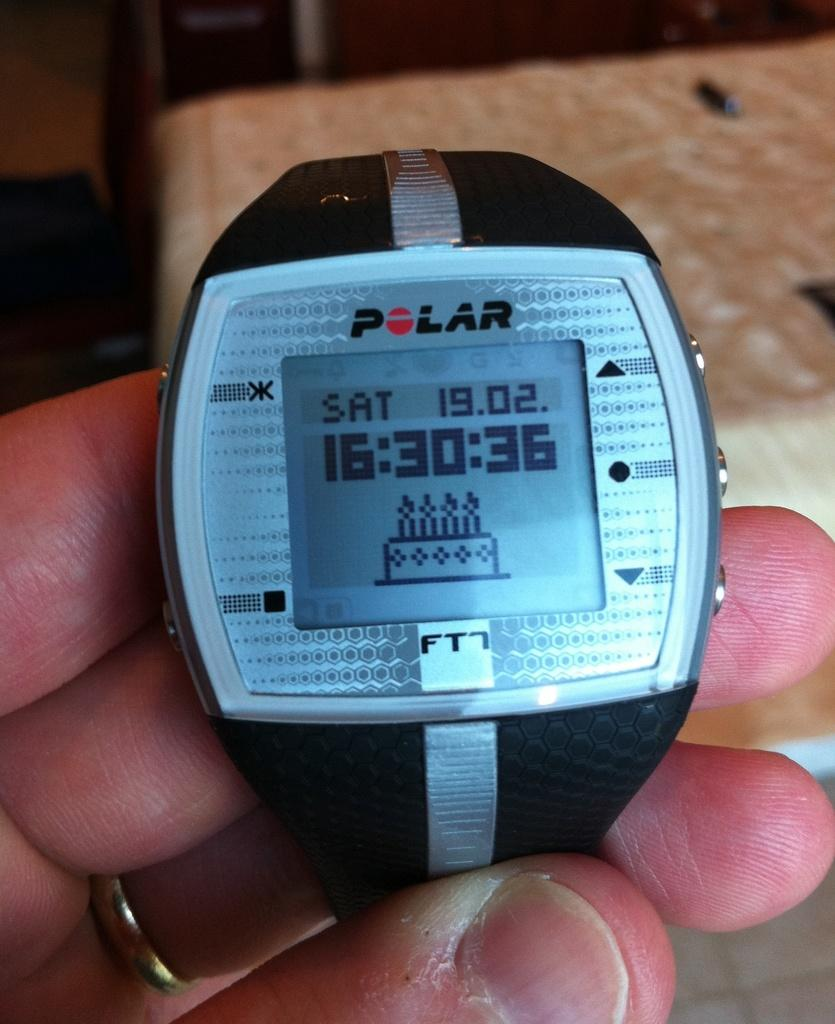<image>
Describe the image concisely. Person holding a stop watch wihch says POLAR on it. 